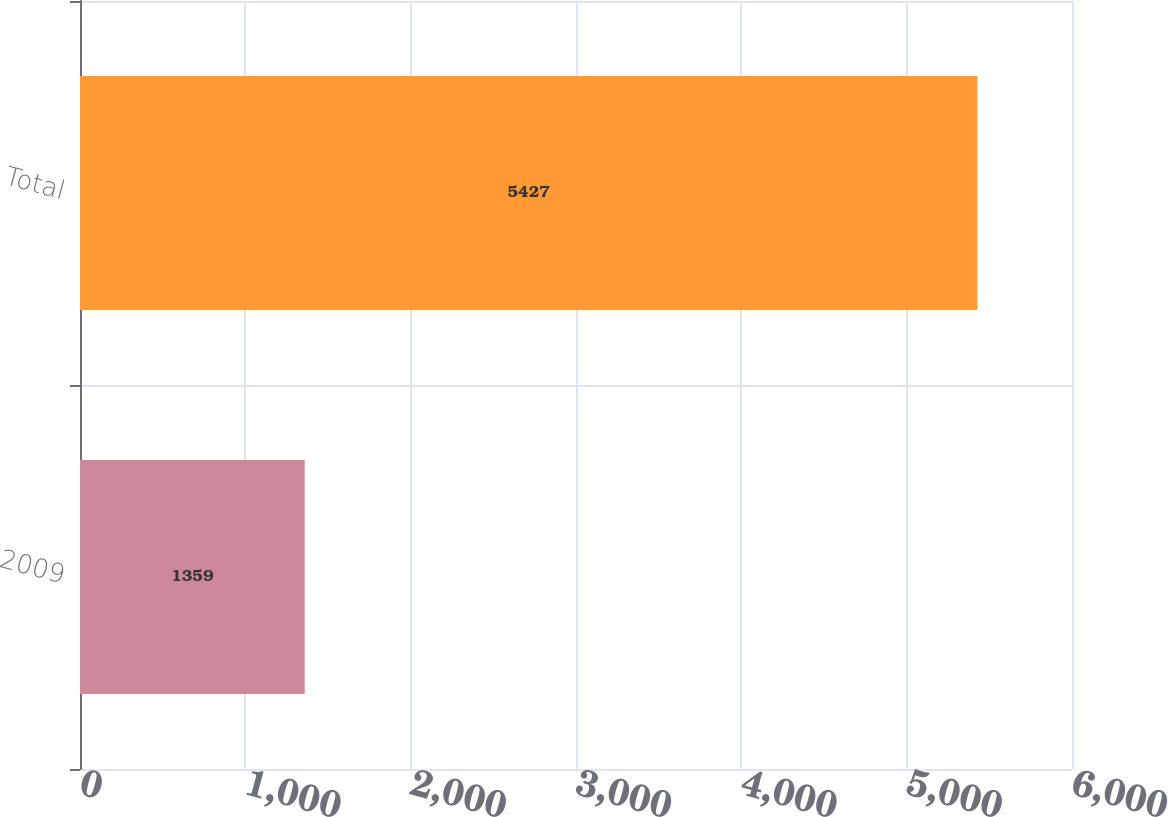Convert chart. <chart><loc_0><loc_0><loc_500><loc_500><bar_chart><fcel>2009<fcel>Total<nl><fcel>1359<fcel>5427<nl></chart> 